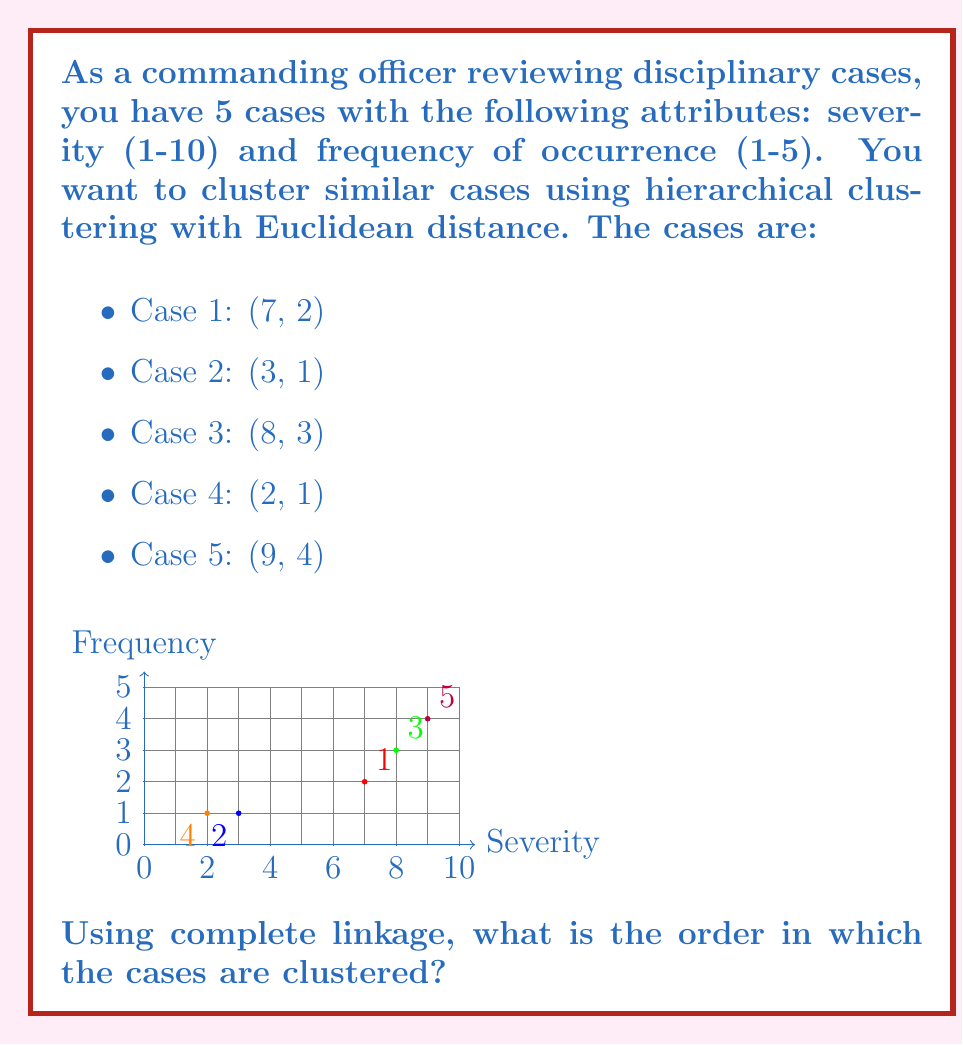Give your solution to this math problem. To cluster the cases using hierarchical clustering with complete linkage, we follow these steps:

1) Calculate the Euclidean distance between all pairs of points:

   $d_{ij} = \sqrt{(x_i - x_j)^2 + (y_i - y_j)^2}$

2) Find the two closest points and cluster them.

3) Update the distance matrix using complete linkage: the distance between clusters is the maximum distance between their members.

4) Repeat steps 2-3 until all points are in one cluster.

Step 1: Calculate distances
$$\begin{array}{c|ccccc}
  & 1 & 2 & 3 & 4 & 5 \\
\hline
1 & 0 & 4.12 & 1.41 & 5.10 & 2.83 \\
2 & 4.12 & 0 & 5.39 & 1.00 & 6.71 \\
3 & 1.41 & 5.39 & 0 & 6.32 & 1.41 \\
4 & 5.10 & 1.00 & 6.32 & 0 & 7.62 \\
5 & 2.83 & 6.71 & 1.41 & 7.62 & 0 \\
\end{array}$$

Step 2-4: Clustering
1. Closest pair: Cases 2 and 4 (distance 1.00). Cluster them.
2. Next closest: Cases 1 and 3 (distance 1.41). Cluster them.
3. Cases 3 and 5 are also at distance 1.41, but we've already clustered 3. The next step is to join 5 to the cluster (1,3).
4. Finally, join the two remaining clusters (2,4) and (1,3,5).

Therefore, the clustering order is: (2,4), (1,3), (1,3,5), (1,2,3,4,5).
Answer: (2,4), (1,3), (1,3,5), (1,2,3,4,5) 